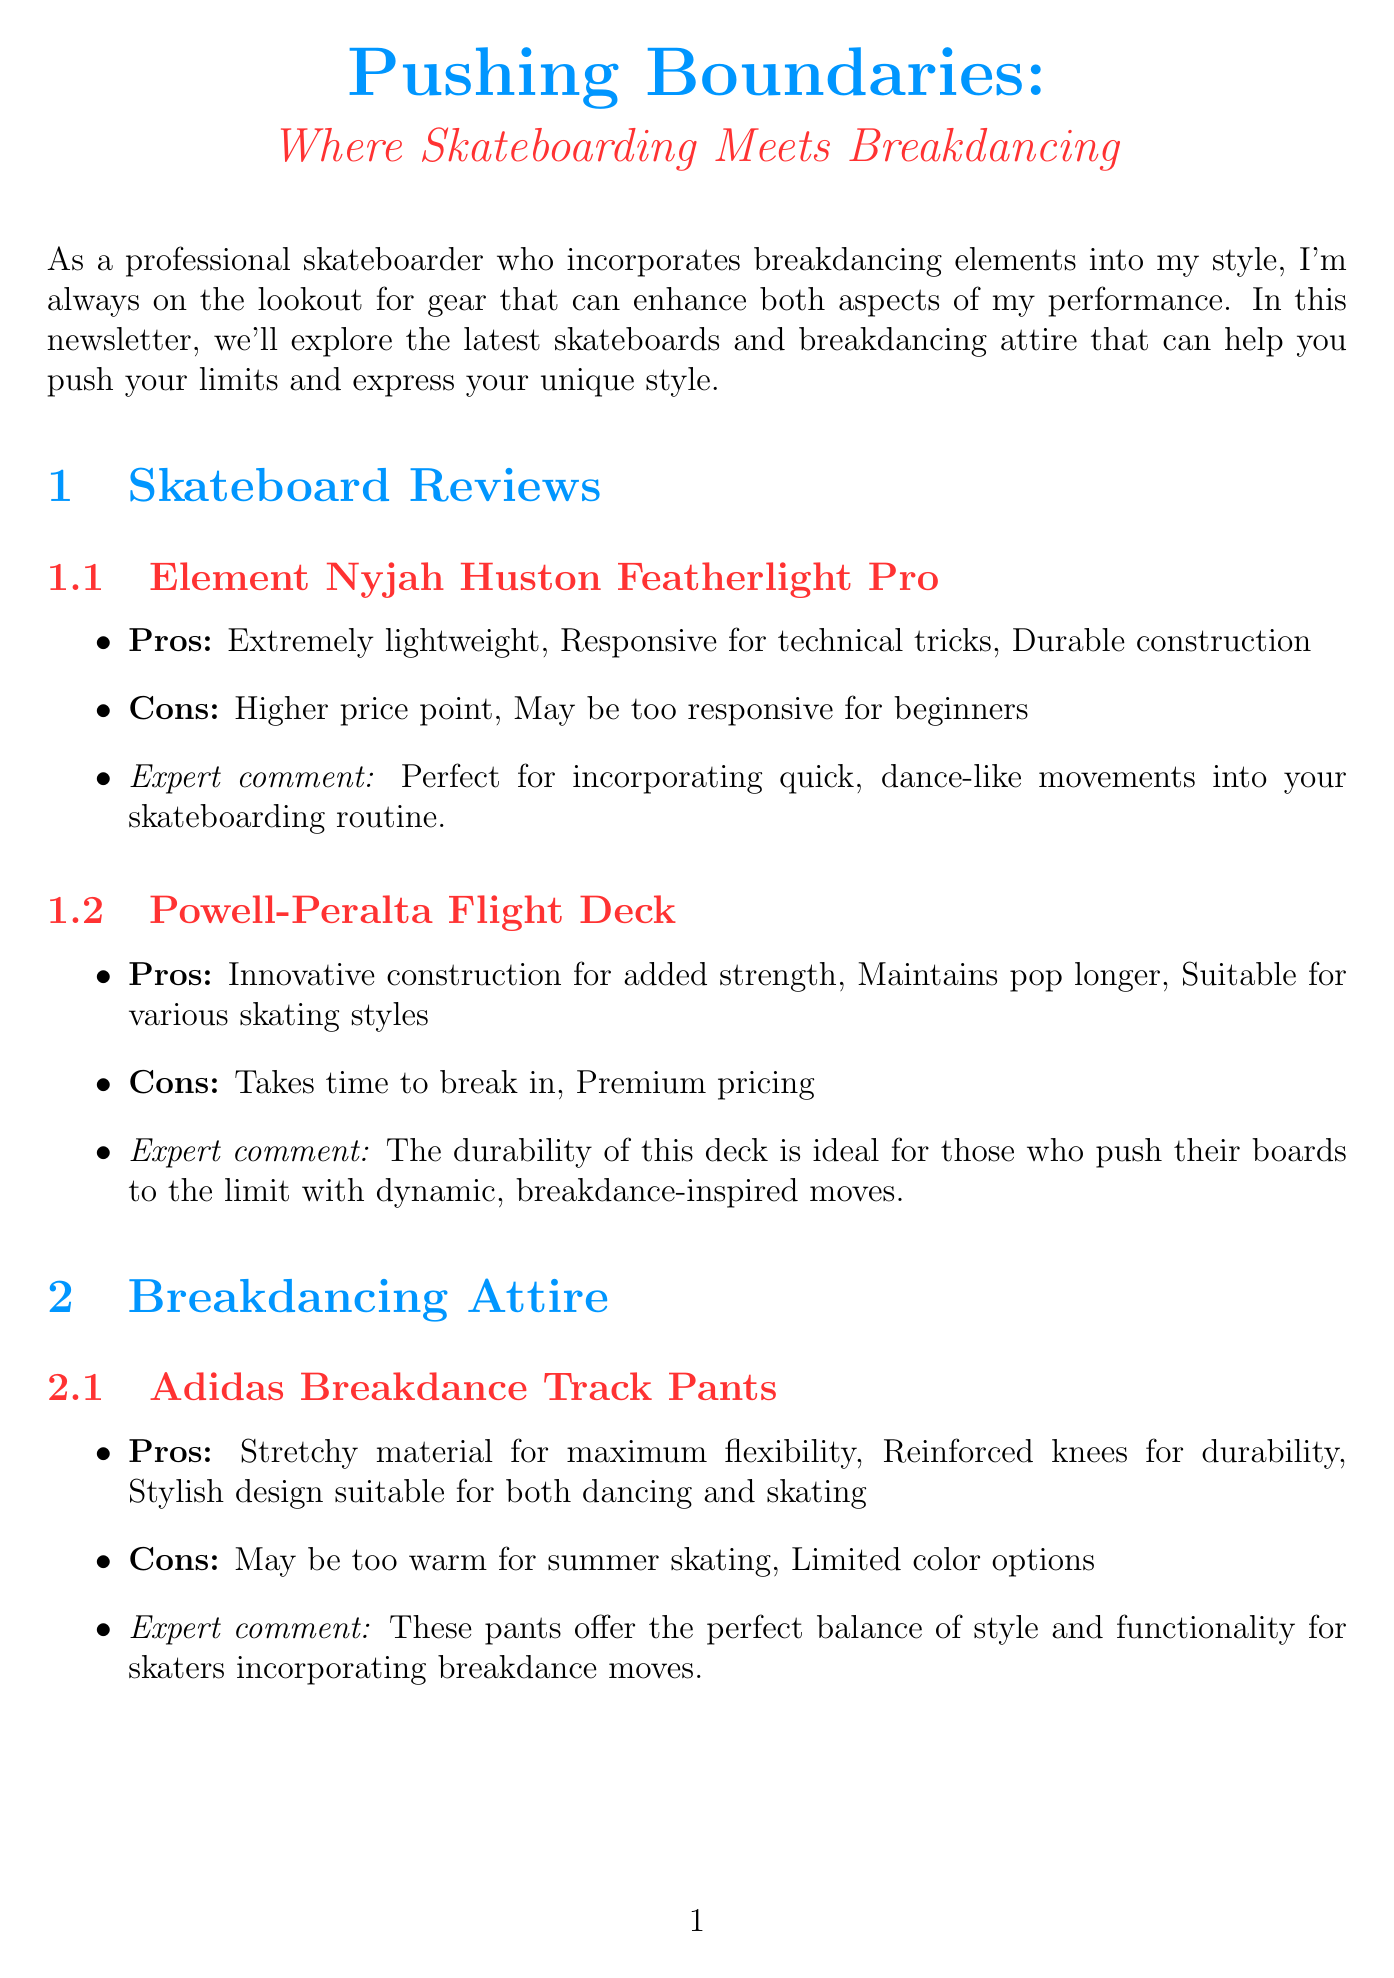What is the title of the newsletter? The title of the newsletter is stated in the introduction section, which is "Pushing Boundaries: Where Skateboarding Meets Breakdancing."
Answer: Pushing Boundaries: Where Skateboarding Meets Breakdancing What brand offers the "Dual Certified Helmet"? The document mentions the brand associated with the "Dual Certified Helmet," which is "Triple Eight."
Answer: Triple Eight What is a pro of the Element skateboard? The pros for the Element skateboard are outlined in the review, and one of them is "Extremely lightweight."
Answer: Extremely lightweight Which brand has a breakdancing attire item listed in the newsletter? The document lists breakdancing attire from two brands; one of them is "Adidas."
Answer: Adidas What is a con of the Powell-Peralta Flight Deck? The cons for the Powell-Peralta Flight Deck include "Takes time to break in."
Answer: Takes time to break in Why are the Adidas Breakdance Track Pants recommended? The expert comment mentions they offer "the perfect balance of style and functionality for skaters incorporating breakdance moves."
Answer: Perfect balance of style and functionality Which item is described as essential for protection? The document refers to the "Dual Certified Helmet" as essential for protecting yourself.
Answer: Dual Certified Helmet What is a recommendation for Mob Grip? The expert recommendation states it is "A must-have for skaters looking to incorporate more fluid, dance-like movements into their style."
Answer: A must-have for skaters looking to incorporate more fluid, dance-like movements into their style 